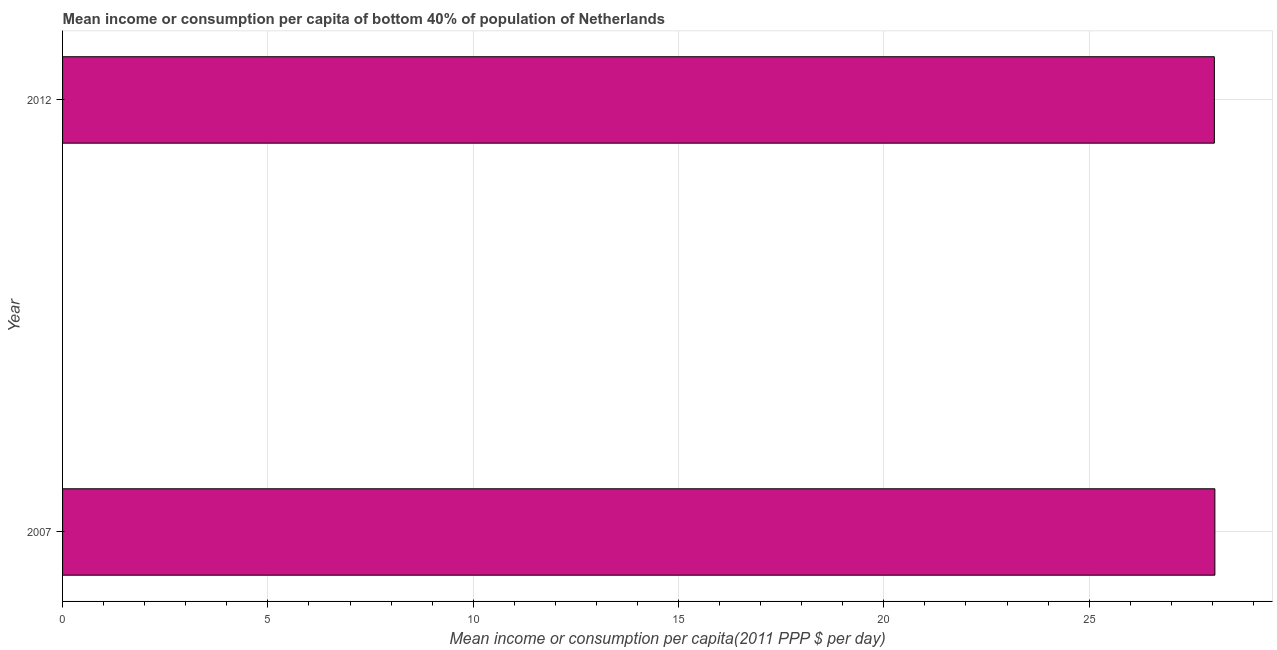Does the graph contain any zero values?
Give a very brief answer. No. What is the title of the graph?
Give a very brief answer. Mean income or consumption per capita of bottom 40% of population of Netherlands. What is the label or title of the X-axis?
Provide a succinct answer. Mean income or consumption per capita(2011 PPP $ per day). What is the mean income or consumption in 2012?
Give a very brief answer. 28.05. Across all years, what is the maximum mean income or consumption?
Offer a very short reply. 28.06. Across all years, what is the minimum mean income or consumption?
Your answer should be very brief. 28.05. In which year was the mean income or consumption minimum?
Make the answer very short. 2012. What is the sum of the mean income or consumption?
Provide a short and direct response. 56.11. What is the difference between the mean income or consumption in 2007 and 2012?
Your answer should be compact. 0.01. What is the average mean income or consumption per year?
Your answer should be compact. 28.06. What is the median mean income or consumption?
Offer a terse response. 28.06. In how many years, is the mean income or consumption greater than 14 $?
Provide a succinct answer. 2. Do a majority of the years between 2007 and 2012 (inclusive) have mean income or consumption greater than 10 $?
Offer a terse response. Yes. What is the ratio of the mean income or consumption in 2007 to that in 2012?
Offer a terse response. 1. In how many years, is the mean income or consumption greater than the average mean income or consumption taken over all years?
Your response must be concise. 1. Are the values on the major ticks of X-axis written in scientific E-notation?
Make the answer very short. No. What is the Mean income or consumption per capita(2011 PPP $ per day) in 2007?
Your response must be concise. 28.06. What is the Mean income or consumption per capita(2011 PPP $ per day) in 2012?
Give a very brief answer. 28.05. What is the difference between the Mean income or consumption per capita(2011 PPP $ per day) in 2007 and 2012?
Your response must be concise. 0.01. 